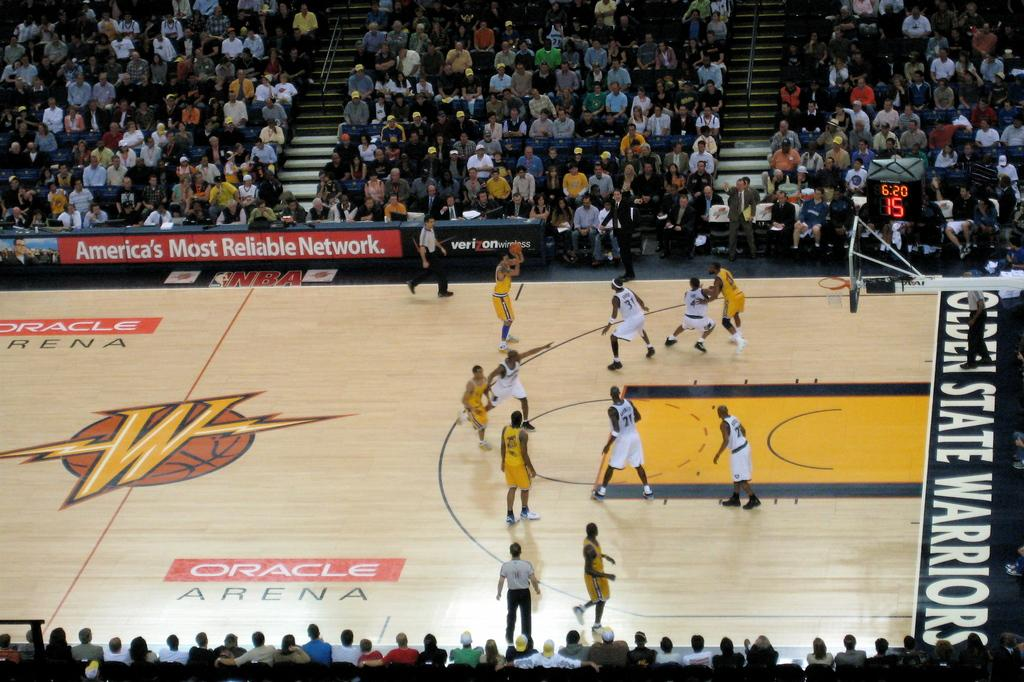<image>
Provide a brief description of the given image. The Golden States Warriors are playing basketball aganst another team. 